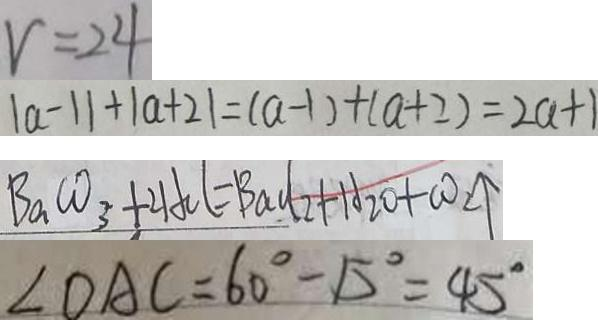Convert formula to latex. <formula><loc_0><loc_0><loc_500><loc_500>v = 2 4 
 \vert a - 1 \vert + \vert a + 2 \vert = ( a - 1 ) + ( a + 2 ) = 2 a + 1 
 B a C O _ { 3 } + 2 H C l = B a C l _ { 2 } + H _ { 2 } O + C O _ { 2 } \uparrow 
 \angle O A C = 6 0 ^ { \circ } - 1 5 ^ { \circ } = 4 5 ^ { \circ }</formula> 